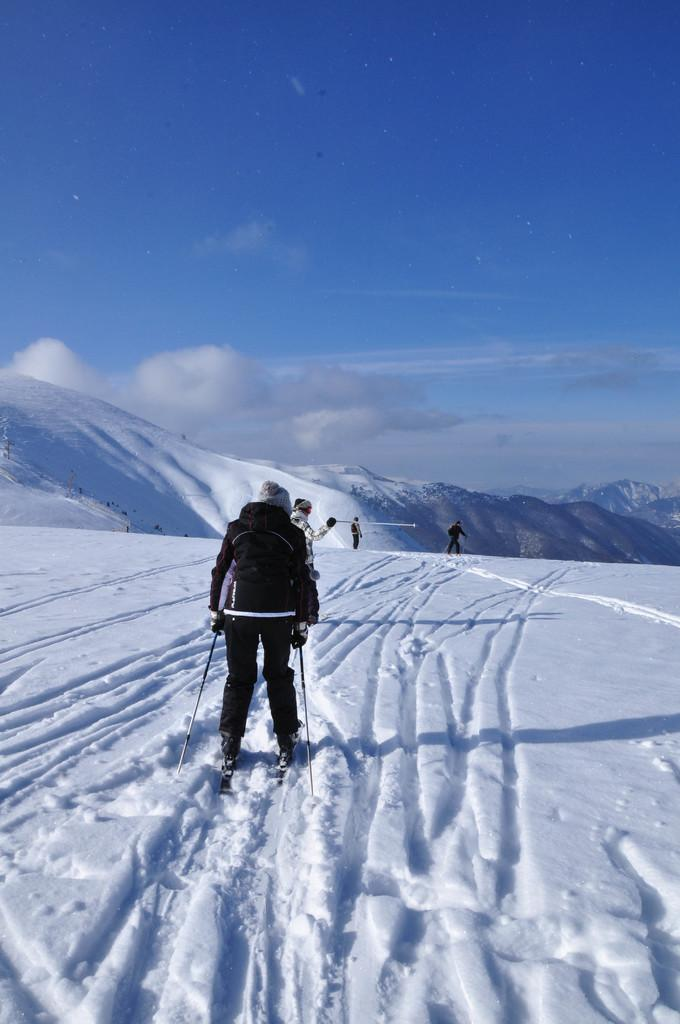What type of environment is depicted in the image? The image is of an outdoor scene. What is covering the ground in the foreground? There is snow in the foreground. What activity is the person in the foreground engaged in? A person is skiing in the foreground. What can be seen in the sky in the image? Clouds are present in the sky. What is visible in the background of the image? There are hills and other people in the background. What type of question is being asked by the person in the image? There is no person asking a question in the image; it depicts a person skiing in the snow. Can you provide an example of a war that is taking place in the image? There is no war depicted in the image; it is a peaceful outdoor scene with a person skiing and other people in the background. 